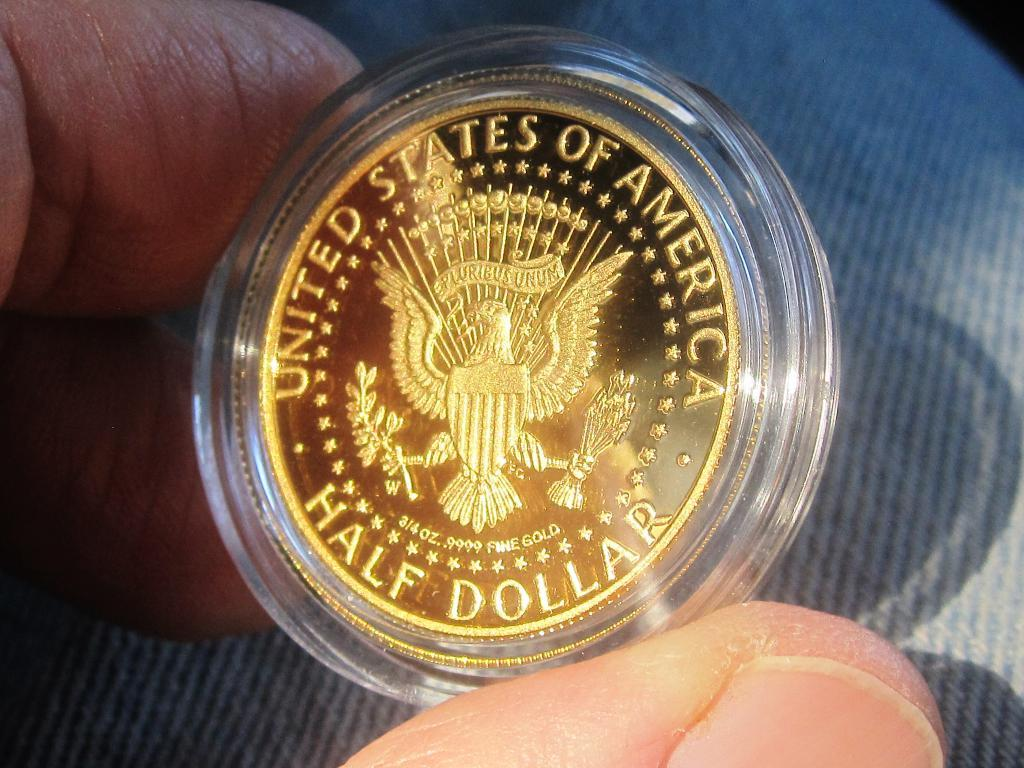Provide a one-sentence caption for the provided image. A hand is holding a US half dollar gold coin in its clear casing. 